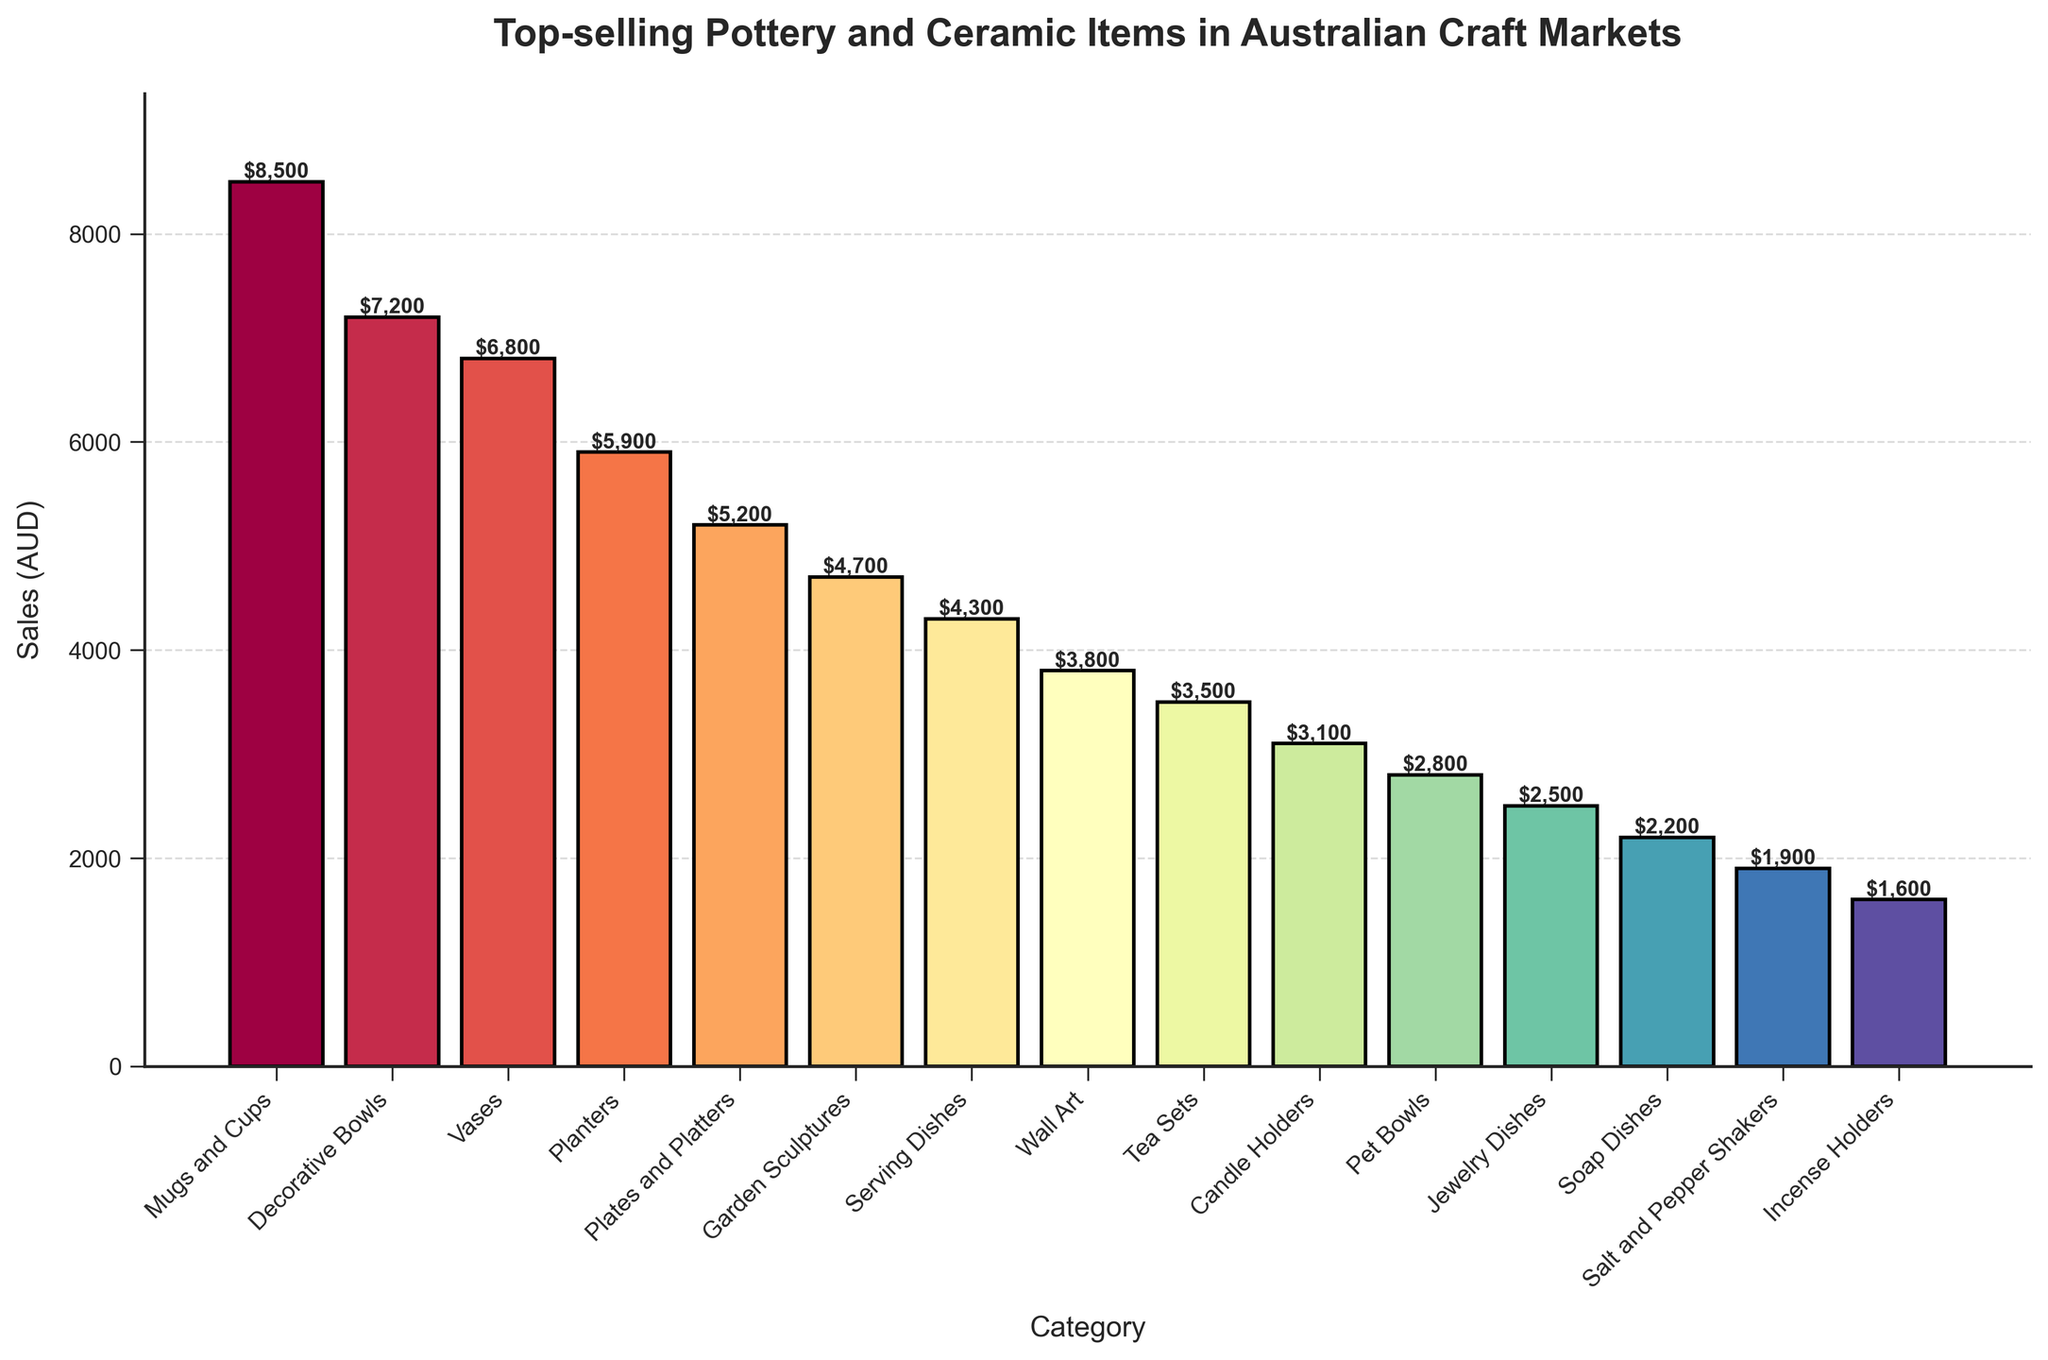Which category has the highest sales? By looking at the tallest bar in the bar chart, we see that "Mugs and Cups" has the highest sales value of $8,500 AUD.
Answer: Mugs and Cups What is the difference in sales between Decorative Bowls and Vases? From the bar chart, the sales for Decorative Bowls are $7,200 AUD and for Vases are $6,800 AUD. The difference is $7,200 - $6,800 = $400 AUD.
Answer: $400 AUD How much more did Planters sell than Candle Holders? According to the chart, Planters sold $5,900 AUD, and Candle Holders sold $3,100 AUD. Therefore, Planters sold $5,900 - $3,100 = $2,800 AUD more.
Answer: $2,800 AUD What are the total sales of the top three categories? The top three categories are "Mugs and Cups," "Decorative Bowls," and "Vases." Their sales are $8,500, $7,200, and $6,800 AUD respectively. So, the total sales are $8,500 + $7,200 + $6,800 = $22,500 AUD.
Answer: $22,500 AUD Which category ranks fifth in terms of sales? Looking at the heights of the bars, "Plates and Platters" ranks fifth with sales of $5,200 AUD.
Answer: Plates and Platters Are sales of Jewelry Dishes higher or lower than Soap Dishes? By comparing the height of their respective bars, Jewelry Dishes have sales of $2,500 AUD, whereas Soap Dishes have sales of $2,200 AUD. Thus, Jewelry Dishes' sales are higher.
Answer: Higher What is the combined sales value of Wall Art and Tea Sets? From the chart, Wall Art has $3,800 AUD in sales and Tea Sets have $3,500 AUD. Therefore, their combined sales value is $3,800 + $3,500 = $7,300 AUD.
Answer: $7,300 AUD Find the average sales of the bottom three categories. The bottom three categories are "Incense Holders," "Salt and Pepper Shakers," and "Soap Dishes," with sales of $1,600, $1,900, and $2,200 AUD respectively. First, sum these values ($1,600 + $1,900 + $2,200 = $5,700 AUD), and then divide by three to find the average: $5,700 / 3 = $1,900 AUD.
Answer: $1,900 AUD Which categories have sales exceeding 5000 AUD? By visually inspecting the bars, the categories with sales exceeding $5,000 AUD are "Mugs and Cups," "Decorative Bowls," "Vases," "Planters," and "Plates and Platters."
Answer: Mugs and Cups, Decorative Bowls, Vases, Planters, Plates and Platters 